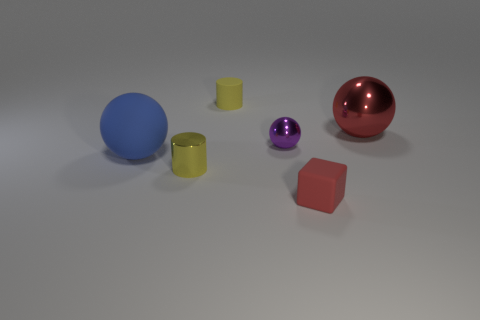Add 1 red metallic objects. How many objects exist? 7 Subtract all blocks. How many objects are left? 5 Add 2 blue matte balls. How many blue matte balls are left? 3 Add 2 tiny yellow cylinders. How many tiny yellow cylinders exist? 4 Subtract 0 cyan cylinders. How many objects are left? 6 Subtract all purple spheres. Subtract all metallic cylinders. How many objects are left? 4 